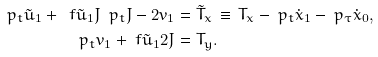Convert formula to latex. <formula><loc_0><loc_0><loc_500><loc_500>\ p _ { t } \tilde { u } _ { 1 } + \ f { \tilde { u } _ { 1 } } { J } \ p _ { t } J - 2 v _ { 1 } & = \tilde { T } _ { x } \, \equiv \, T _ { x } - \ p _ { t } \dot { x } _ { 1 } - \ p _ { \tau } \dot { x } _ { 0 } , \\ \ p _ { t } v _ { 1 } + \ f { \tilde { u } _ { 1 } } { 2 J } & = T _ { y } .</formula> 